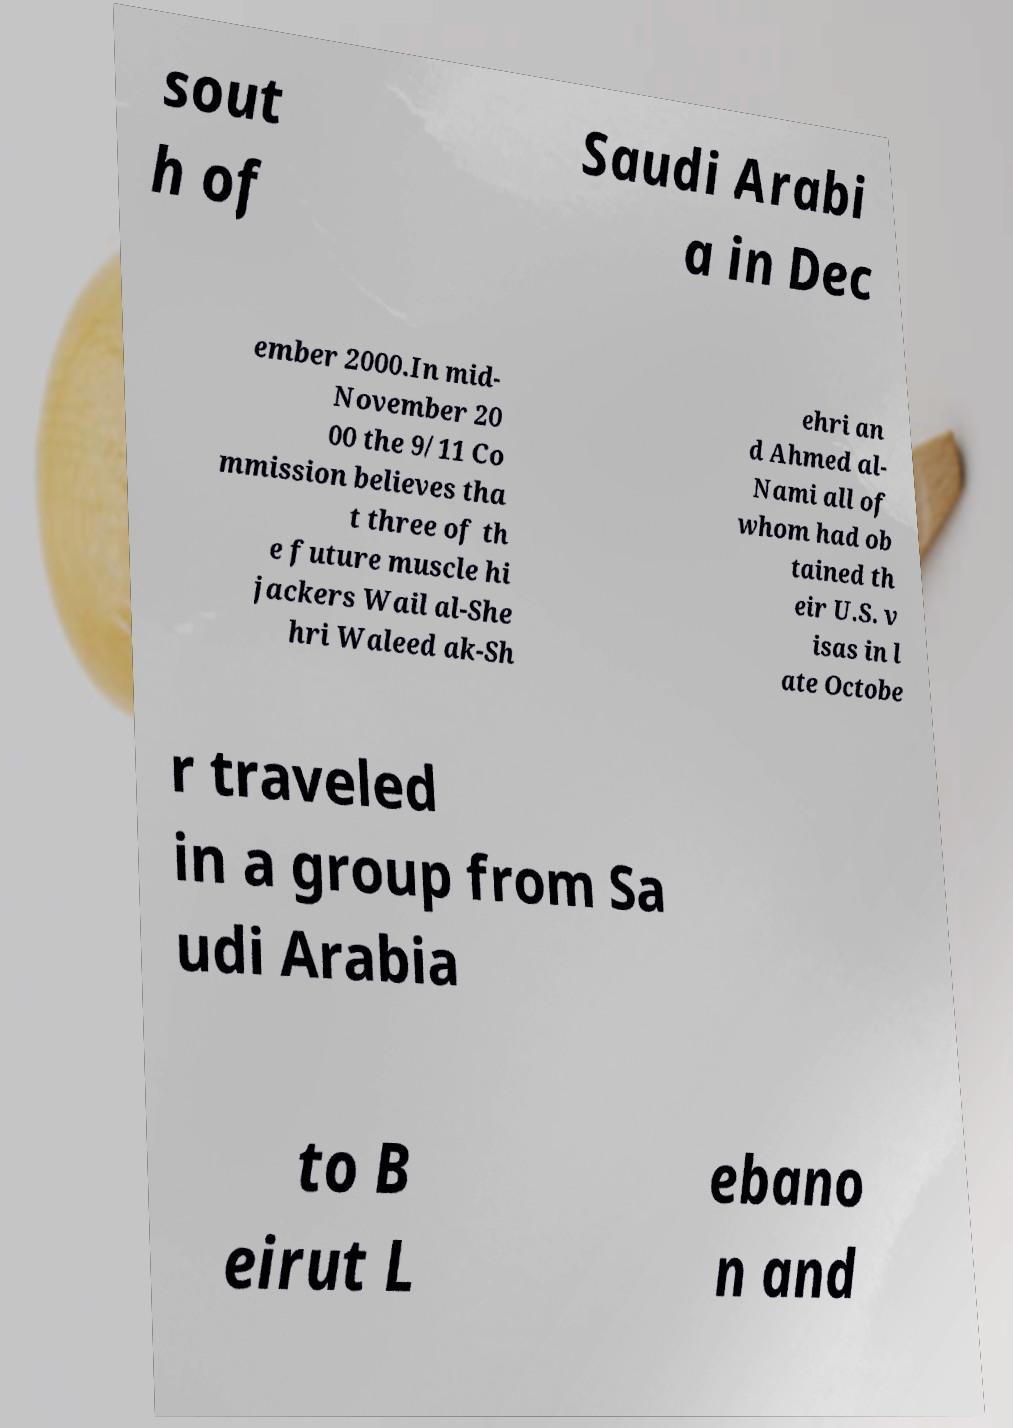Could you extract and type out the text from this image? sout h of Saudi Arabi a in Dec ember 2000.In mid- November 20 00 the 9/11 Co mmission believes tha t three of th e future muscle hi jackers Wail al-She hri Waleed ak-Sh ehri an d Ahmed al- Nami all of whom had ob tained th eir U.S. v isas in l ate Octobe r traveled in a group from Sa udi Arabia to B eirut L ebano n and 